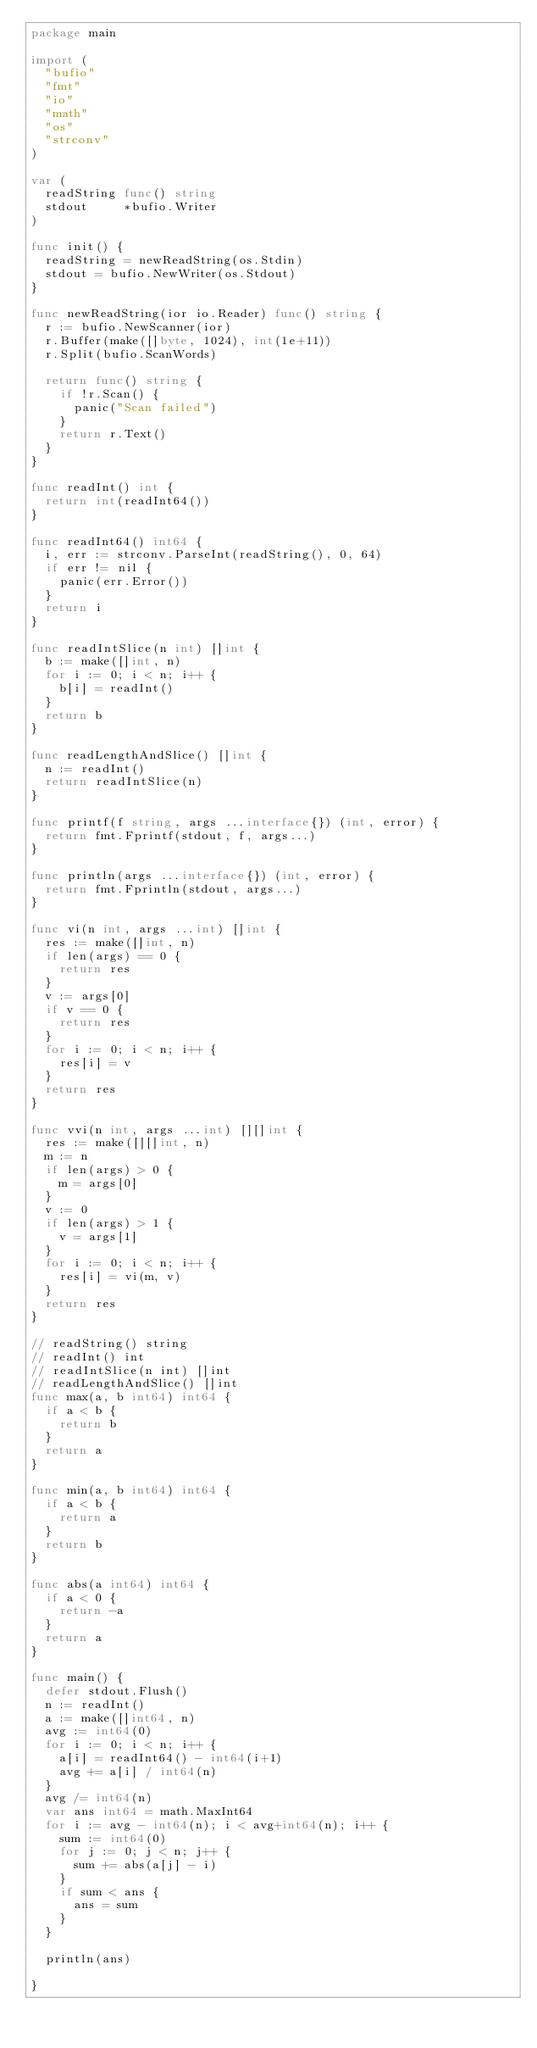<code> <loc_0><loc_0><loc_500><loc_500><_Go_>package main

import (
	"bufio"
	"fmt"
	"io"
	"math"
	"os"
	"strconv"
)

var (
	readString func() string
	stdout     *bufio.Writer
)

func init() {
	readString = newReadString(os.Stdin)
	stdout = bufio.NewWriter(os.Stdout)
}

func newReadString(ior io.Reader) func() string {
	r := bufio.NewScanner(ior)
	r.Buffer(make([]byte, 1024), int(1e+11))
	r.Split(bufio.ScanWords)

	return func() string {
		if !r.Scan() {
			panic("Scan failed")
		}
		return r.Text()
	}
}

func readInt() int {
	return int(readInt64())
}

func readInt64() int64 {
	i, err := strconv.ParseInt(readString(), 0, 64)
	if err != nil {
		panic(err.Error())
	}
	return i
}

func readIntSlice(n int) []int {
	b := make([]int, n)
	for i := 0; i < n; i++ {
		b[i] = readInt()
	}
	return b
}

func readLengthAndSlice() []int {
	n := readInt()
	return readIntSlice(n)
}

func printf(f string, args ...interface{}) (int, error) {
	return fmt.Fprintf(stdout, f, args...)
}

func println(args ...interface{}) (int, error) {
	return fmt.Fprintln(stdout, args...)
}

func vi(n int, args ...int) []int {
	res := make([]int, n)
	if len(args) == 0 {
		return res
	}
	v := args[0]
	if v == 0 {
		return res
	}
	for i := 0; i < n; i++ {
		res[i] = v
	}
	return res
}

func vvi(n int, args ...int) [][]int {
	res := make([][]int, n)
	m := n
	if len(args) > 0 {
		m = args[0]
	}
	v := 0
	if len(args) > 1 {
		v = args[1]
	}
	for i := 0; i < n; i++ {
		res[i] = vi(m, v)
	}
	return res
}

// readString() string
// readInt() int
// readIntSlice(n int) []int
// readLengthAndSlice() []int
func max(a, b int64) int64 {
	if a < b {
		return b
	}
	return a
}

func min(a, b int64) int64 {
	if a < b {
		return a
	}
	return b
}

func abs(a int64) int64 {
	if a < 0 {
		return -a
	}
	return a
}

func main() {
	defer stdout.Flush()
	n := readInt()
	a := make([]int64, n)
	avg := int64(0)
	for i := 0; i < n; i++ {
		a[i] = readInt64() - int64(i+1)
		avg += a[i] / int64(n)
	}
	avg /= int64(n)
	var ans int64 = math.MaxInt64
	for i := avg - int64(n); i < avg+int64(n); i++ {
		sum := int64(0)
		for j := 0; j < n; j++ {
			sum += abs(a[j] - i)
		}
		if sum < ans {
			ans = sum
		}
	}

	println(ans)

}
</code> 